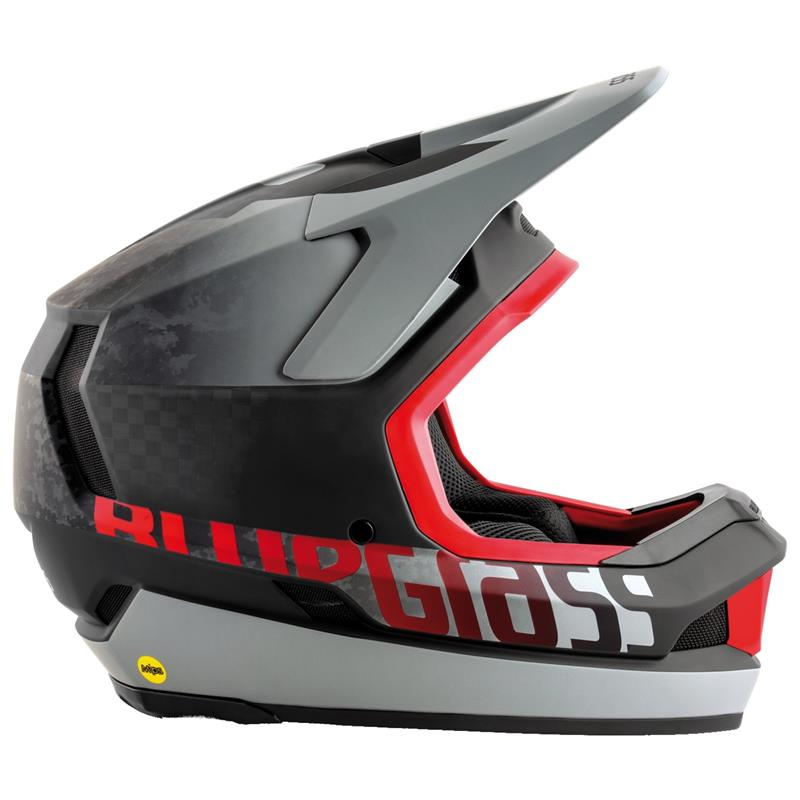What materials might contribute to the construction of this helmet to meet safety standards? This helmet likely incorporates a combination of materials designed to maximize both durability and impact absorption. Common materials include a high-strength outer shell made of polycarbonate or fiberglass, which provides structural integrity and disperses impact forces. Inside, you might find an expanded polystyrene (EPS) foam layer that absorbs energy from collisions, reducing the risk of head injuries. Additional comfort and protection are provided by interior padding made from moisture-wicking fabrics. Together, these materials work to meet rigorous safety standards, ensuring optimal protection for the user. 